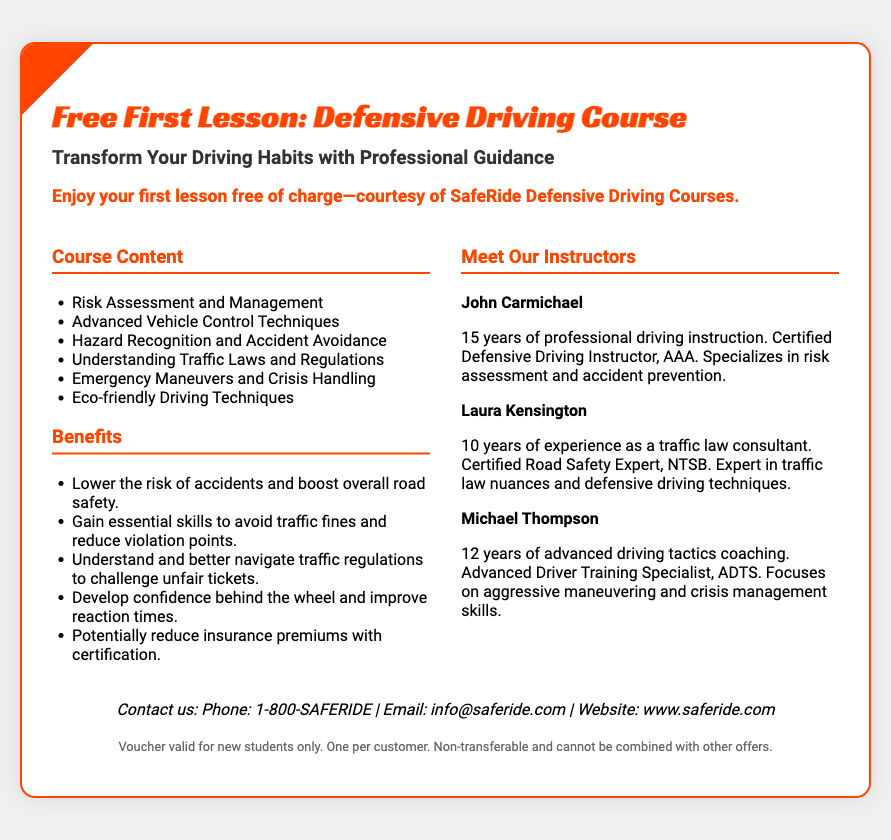What is the title of the course? The title of the course is presented prominently in the heading of the voucher.
Answer: Free First Lesson: Defensive Driving Course Who offers the free lesson? The offer for the free lesson is provided by the organization running the course, mentioned in the offer section.
Answer: SafeRide Defensive Driving Courses How many years of experience does Laura Kensington have? Laura Kensington's years of experience as provided in her profile on the right column of the voucher.
Answer: 10 years What is one of the benefits of the course? The document lists several benefits of the course and this question asks for a specific one from the benefits section.
Answer: Lower the risk of accidents and boost overall road safety What type of instructor is John Carmichael? The instructor's certification and specialization are detailed in his profile.
Answer: Certified Defensive Driving Instructor, AAA How can the course help reduce insurance premiums? The document explains how certification from the course may lead to savings on insurance, clarifying its potential impact on costs.
Answer: Potentially reduce insurance premiums with certification What is the contact number for SafeRide? The contact number can be found in the contact section of the voucher, providing a way for inquiries.
Answer: 1-800-SAFERIDE Is the voucher transferable? The terms outlined in the fine print specify the conditions regarding transferability of the voucher.
Answer: Non-transferable What is the age limit for the voucher? The fine print notes the voucher eligibility criteria affecting who can use it, but it does not mention any specific age limit.
Answer: New students only 